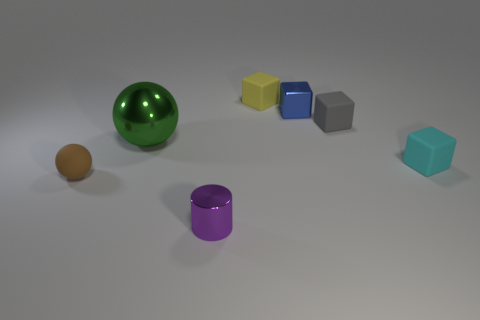Subtract all shiny cubes. How many cubes are left? 3 Add 2 tiny brown rubber balls. How many objects exist? 9 Subtract 0 red blocks. How many objects are left? 7 Subtract all cylinders. How many objects are left? 6 Subtract all cyan blocks. Subtract all blue spheres. How many blocks are left? 3 Subtract all blue blocks. How many cyan cylinders are left? 0 Subtract all tiny objects. Subtract all big purple shiny cylinders. How many objects are left? 1 Add 5 blue metal things. How many blue metal things are left? 6 Add 7 tiny rubber balls. How many tiny rubber balls exist? 8 Subtract all gray cubes. How many cubes are left? 3 